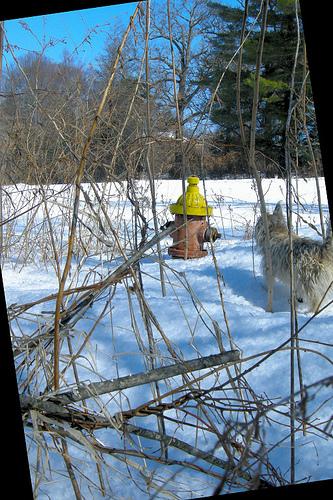Has a snow plow already been by?
Give a very brief answer. No. Is there a dog next to the hydrant?
Answer briefly. Yes. What is the color of hydrate?
Quick response, please. Red and yellow. 